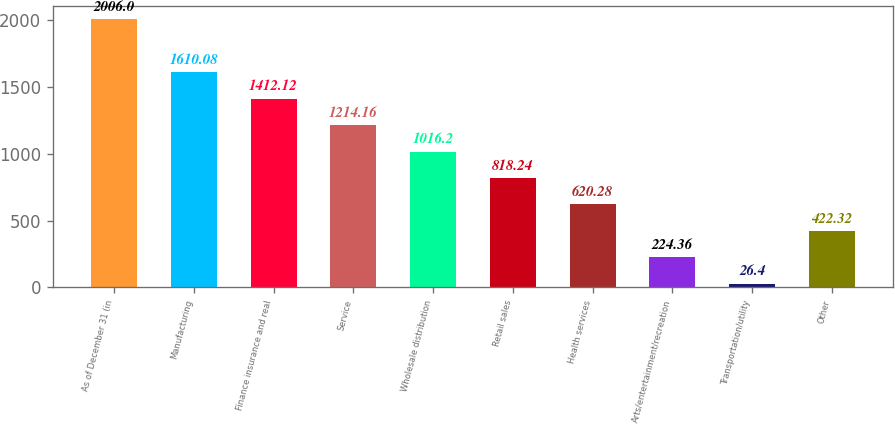Convert chart. <chart><loc_0><loc_0><loc_500><loc_500><bar_chart><fcel>As of December 31 (in<fcel>Manufacturing<fcel>Finance insurance and real<fcel>Service<fcel>Wholesale distribution<fcel>Retail sales<fcel>Health services<fcel>Arts/entertainment/recreation<fcel>Transportation/utility<fcel>Other<nl><fcel>2006<fcel>1610.08<fcel>1412.12<fcel>1214.16<fcel>1016.2<fcel>818.24<fcel>620.28<fcel>224.36<fcel>26.4<fcel>422.32<nl></chart> 